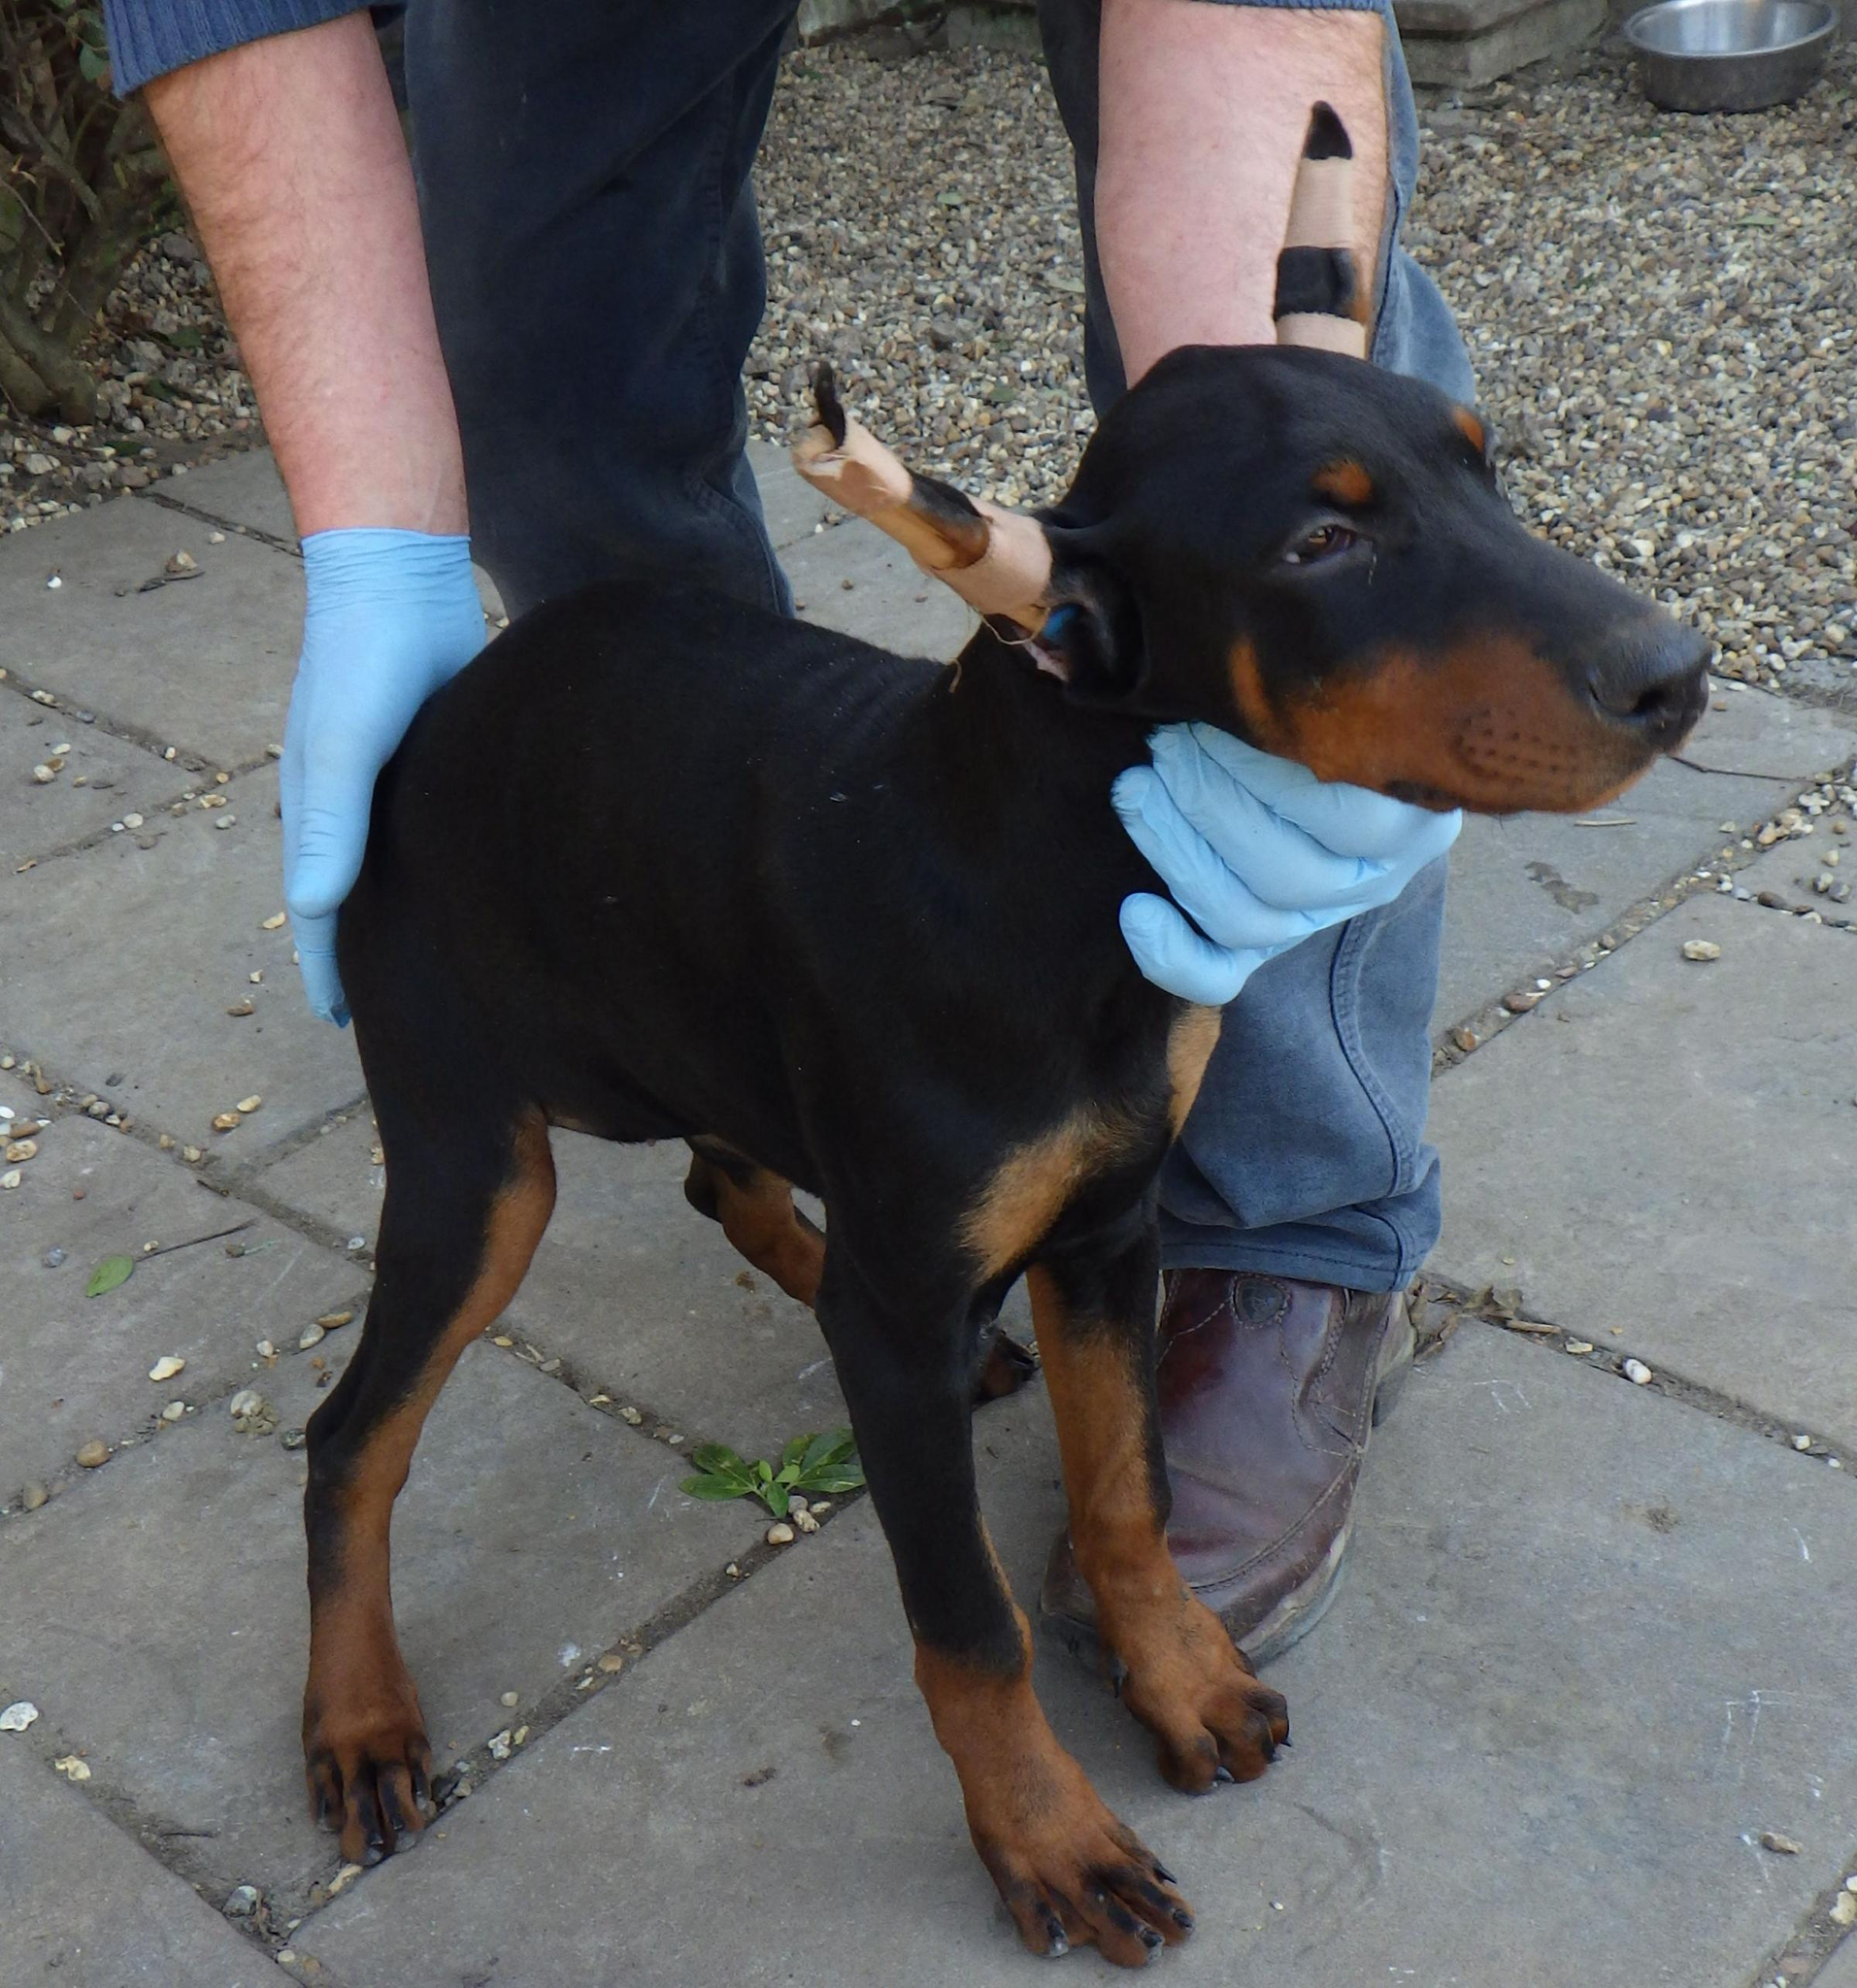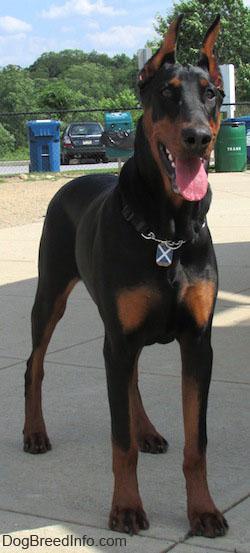The first image is the image on the left, the second image is the image on the right. Considering the images on both sides, is "A person is bending down behind a standing doberman, with one hand holding the front of the dog under its head." valid? Answer yes or no. Yes. The first image is the image on the left, the second image is the image on the right. Assess this claim about the two images: "There are more dogs in the image on the left.". Correct or not? Answer yes or no. No. 